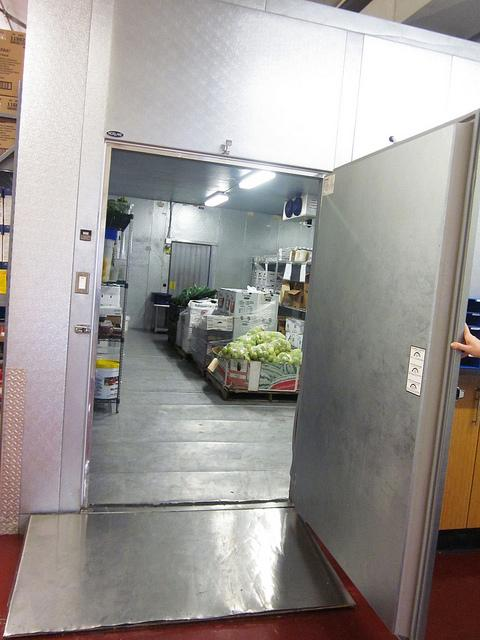What does this door lead to? refrigerator 